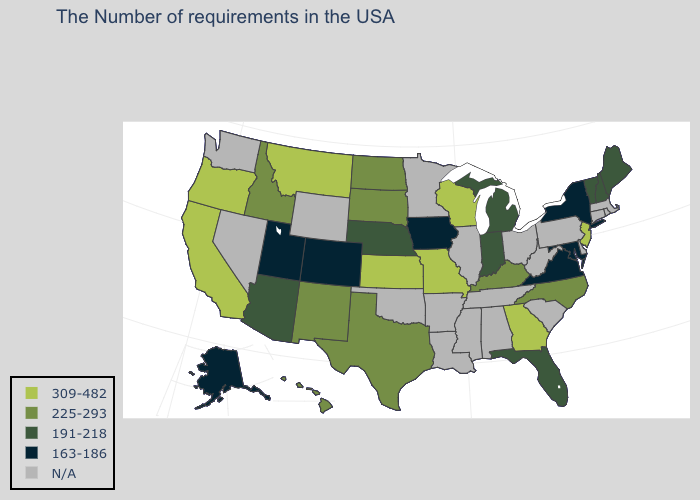What is the highest value in the USA?
Keep it brief. 309-482. Is the legend a continuous bar?
Quick response, please. No. Which states have the lowest value in the USA?
Keep it brief. New York, Maryland, Virginia, Iowa, Colorado, Utah, Alaska. Does the map have missing data?
Concise answer only. Yes. What is the highest value in the West ?
Concise answer only. 309-482. Name the states that have a value in the range 163-186?
Short answer required. New York, Maryland, Virginia, Iowa, Colorado, Utah, Alaska. Which states have the lowest value in the USA?
Concise answer only. New York, Maryland, Virginia, Iowa, Colorado, Utah, Alaska. Which states have the lowest value in the South?
Answer briefly. Maryland, Virginia. What is the lowest value in the MidWest?
Write a very short answer. 163-186. What is the highest value in the USA?
Write a very short answer. 309-482. Among the states that border Utah , which have the highest value?
Keep it brief. New Mexico, Idaho. Name the states that have a value in the range N/A?
Concise answer only. Massachusetts, Rhode Island, Connecticut, Delaware, Pennsylvania, South Carolina, West Virginia, Ohio, Alabama, Tennessee, Illinois, Mississippi, Louisiana, Arkansas, Minnesota, Oklahoma, Wyoming, Nevada, Washington. What is the lowest value in states that border Florida?
Answer briefly. 309-482. 